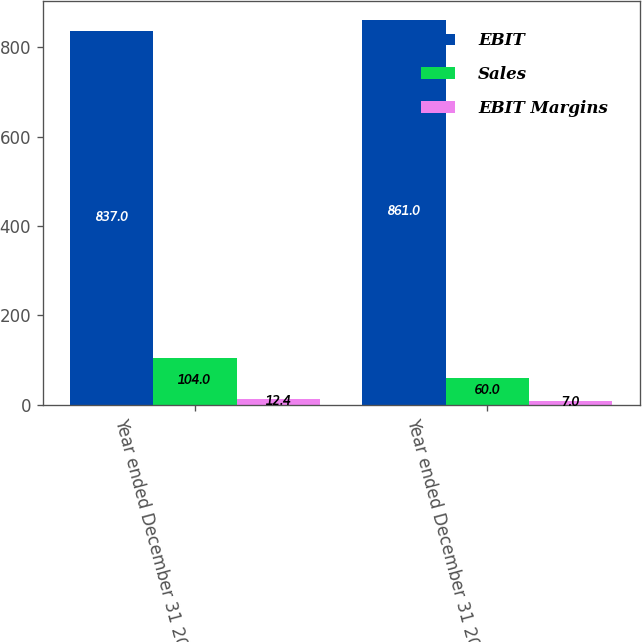Convert chart to OTSL. <chart><loc_0><loc_0><loc_500><loc_500><stacked_bar_chart><ecel><fcel>Year ended December 31 2007<fcel>Year ended December 31 2006<nl><fcel>EBIT<fcel>837<fcel>861<nl><fcel>Sales<fcel>104<fcel>60<nl><fcel>EBIT Margins<fcel>12.4<fcel>7<nl></chart> 